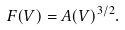Convert formula to latex. <formula><loc_0><loc_0><loc_500><loc_500>F ( V ) = A ( V ) ^ { 3 / 2 } .</formula> 